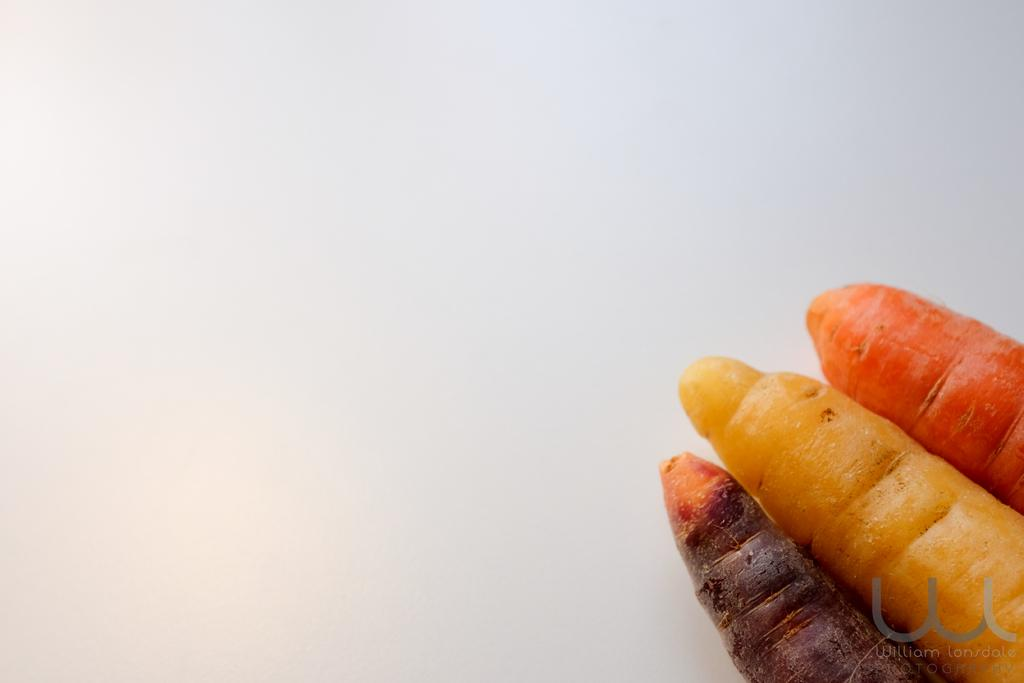What vegetables are present in the image? There are three carrots in the image. Where are the carrots located in the image? The carrots are located on the right side bottom of the image. Are the carrots driving a car in the image? No, the carrots are not driving a car in the image. They are vegetables and do not have the ability to drive. 